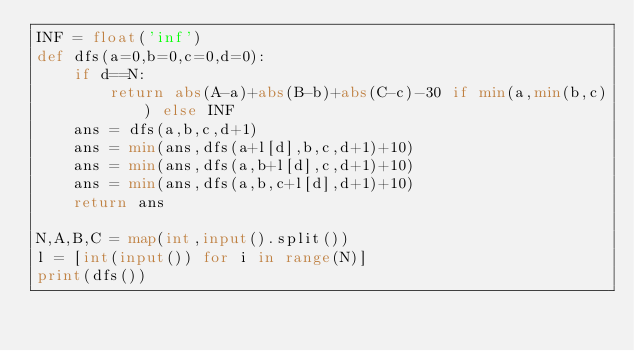<code> <loc_0><loc_0><loc_500><loc_500><_Python_>INF = float('inf')
def dfs(a=0,b=0,c=0,d=0):
    if d==N:
        return abs(A-a)+abs(B-b)+abs(C-c)-30 if min(a,min(b,c)) else INF
    ans = dfs(a,b,c,d+1)
    ans = min(ans,dfs(a+l[d],b,c,d+1)+10)
    ans = min(ans,dfs(a,b+l[d],c,d+1)+10)
    ans = min(ans,dfs(a,b,c+l[d],d+1)+10)
    return ans

N,A,B,C = map(int,input().split())
l = [int(input()) for i in range(N)]
print(dfs())
</code> 